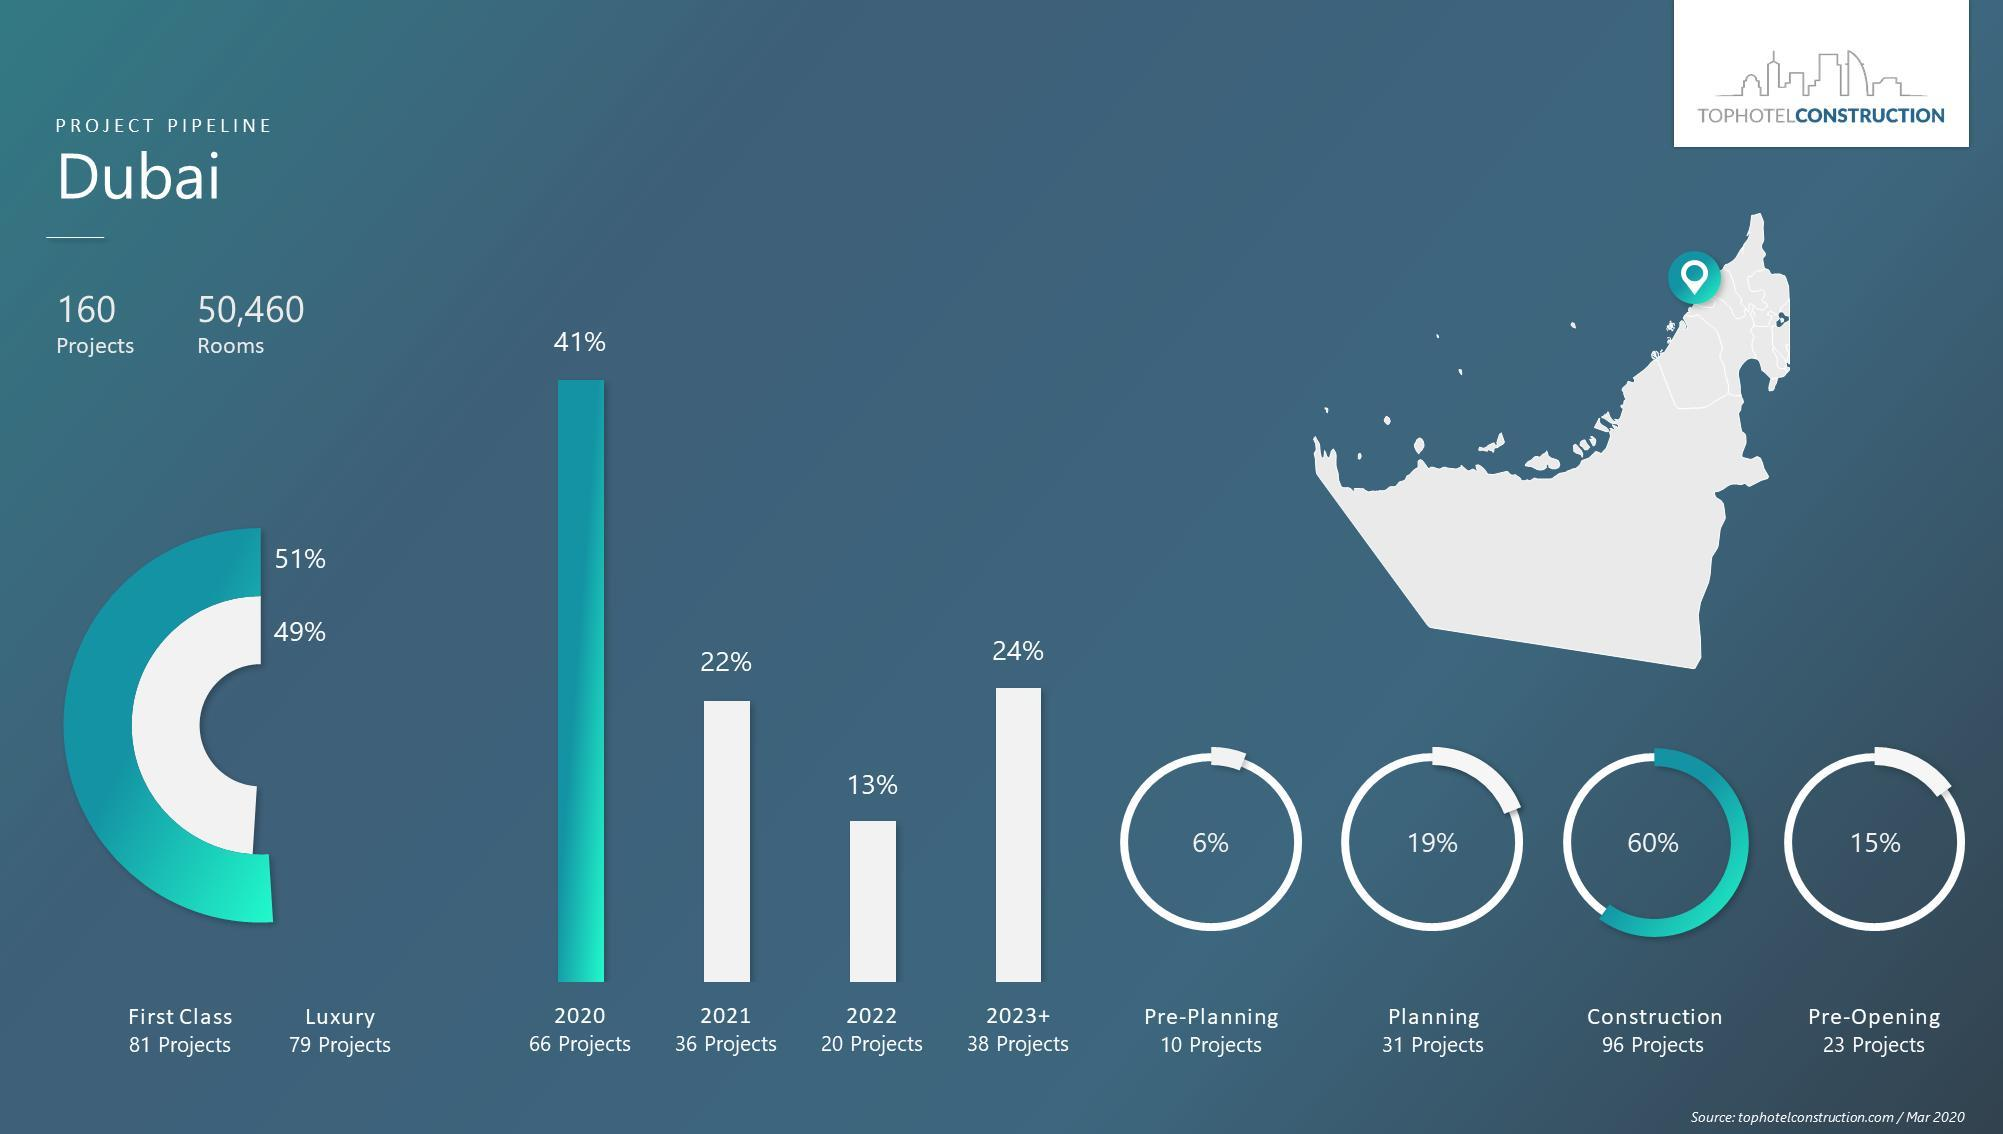What is the number of luxury projects?
Answer the question with a short phrase. 79% What is the number of construction projects? 96 What is the percentage of planning projects? 19% In which year the number of projects is high? 2020 In which year the number of projects is low? 2022 What is the percentage of pre-planning projects? 6% 